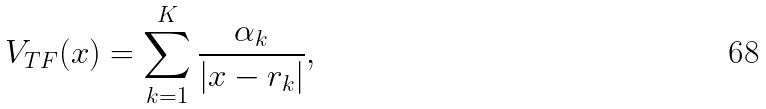Convert formula to latex. <formula><loc_0><loc_0><loc_500><loc_500>V _ { T F } ( x ) = \sum _ { k = 1 } ^ { K } \frac { \alpha _ { k } } { | x - r _ { k } | } ,</formula> 